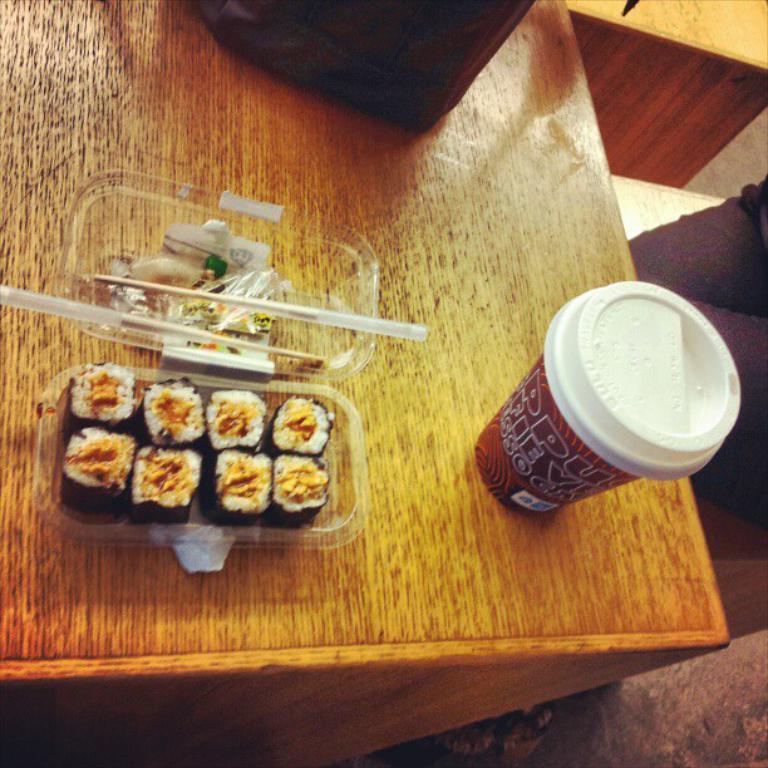In one or two sentences, can you explain what this image depicts? In this image I can see the yellow and brown colored wooden object and on it I can see a cup, a plastic box and a black colored object. In the box I can see few food items which are white, black and yellow in color, chopsticks and few other objects. 